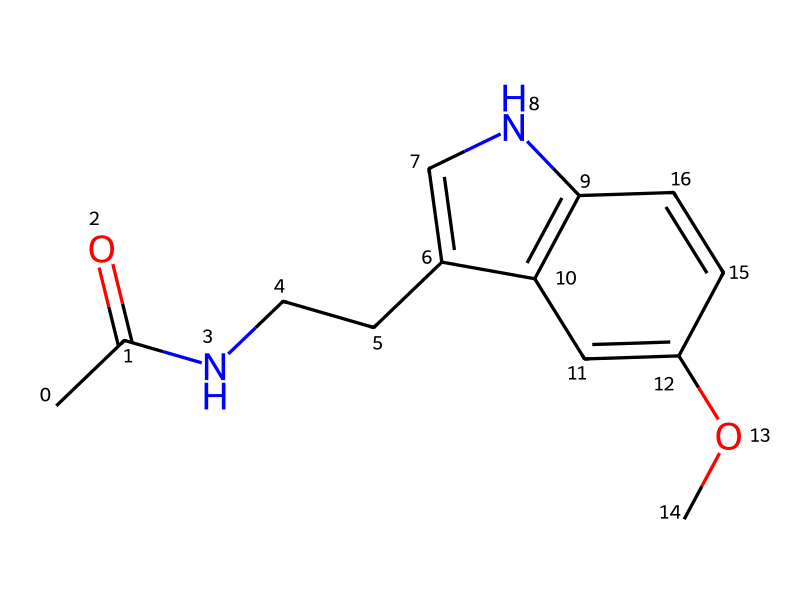What is the molecular formula of this compound? To determine the molecular formula, we first identify the number of each type of atom present in the SMILES representation. The breakdown is as follows: there are 10 carbon (C) atoms, 13 hydrogen (H) atoms, 1 nitrogen (N) atom, and 2 oxygen (O) atoms. Therefore, the molecular formula combines these counts.
Answer: C10H13N2O2 How many rings are present in this structure? Analyzing the SMILES notation, we notice the numbers within the structure indicate the presence of rings. There are two instances of numbers (1 and 2), indicating two rings are interconnected. Hence, the total count of rings is two.
Answer: 2 What is the functional group present in this compound? The structure contains a carbonyl group (C=O) and an amine (NH) as part of its molecular makeup. The presence of these groups indicates that the compound features an acetyl group and an amine functional group. Thus, the dominant functional group can be identified as amide, given that it links nitrogen to the carbonyl.
Answer: amide What does this compound primarily affect in the human body? Melatonin is predominantly associated with the regulation of circadian rhythms and sleep cycles in the human body. Its function relates primarily to the sleep-wake cycle, where it aids in promoting sleep, especially in environments with altered light conditions.
Answer: sleep What is the significance of nitrogen in this molecule? Nitrogen in the molecule contributes to the formation of an amide bond, which is significant for the compound's biological activity and function. Nitrogen atoms in similar compounds often play a key role in biochemical activities, such as signaling and regulation in biosystems.
Answer: regulation 